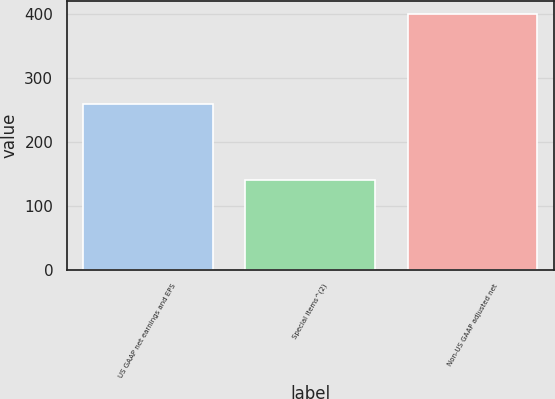Convert chart. <chart><loc_0><loc_0><loc_500><loc_500><bar_chart><fcel>US GAAP net earnings and EPS<fcel>Special items^(2)<fcel>Non-US GAAP adjusted net<nl><fcel>258.1<fcel>140.8<fcel>398.9<nl></chart> 